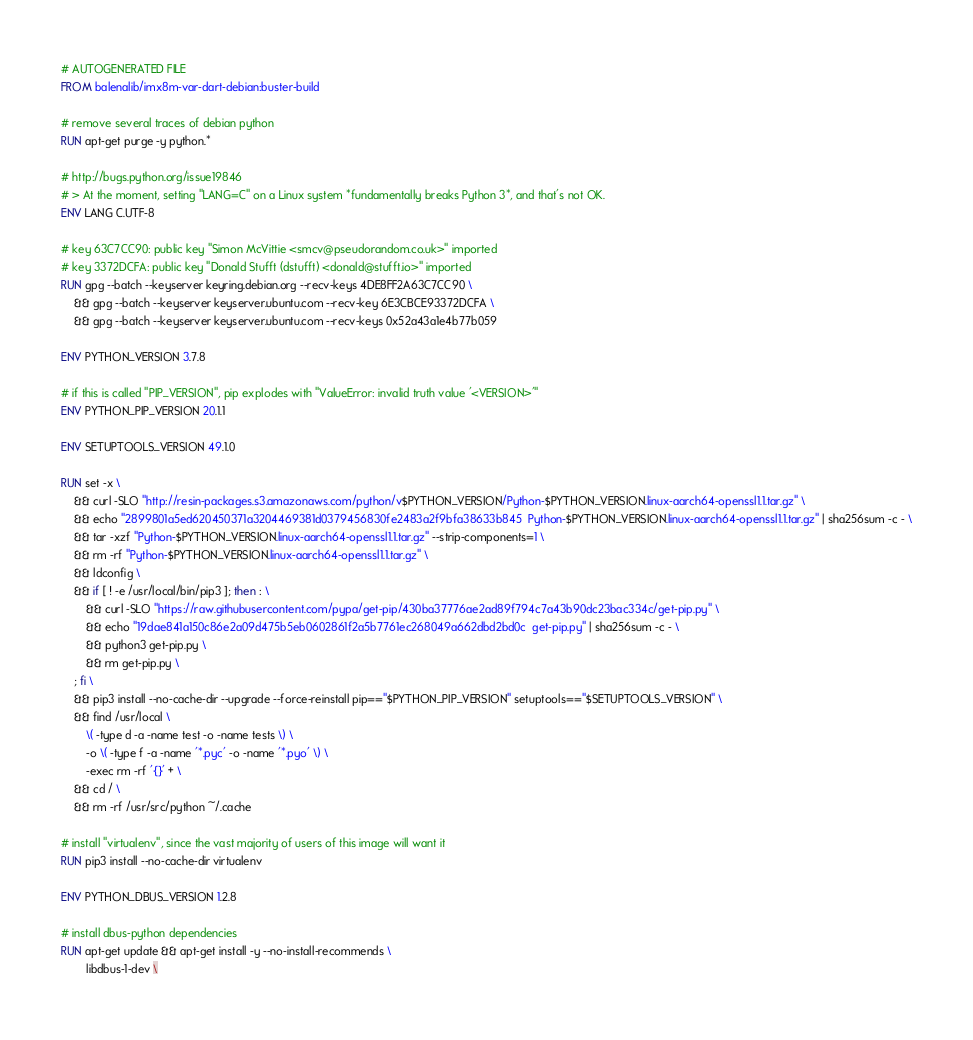<code> <loc_0><loc_0><loc_500><loc_500><_Dockerfile_># AUTOGENERATED FILE
FROM balenalib/imx8m-var-dart-debian:buster-build

# remove several traces of debian python
RUN apt-get purge -y python.*

# http://bugs.python.org/issue19846
# > At the moment, setting "LANG=C" on a Linux system *fundamentally breaks Python 3*, and that's not OK.
ENV LANG C.UTF-8

# key 63C7CC90: public key "Simon McVittie <smcv@pseudorandom.co.uk>" imported
# key 3372DCFA: public key "Donald Stufft (dstufft) <donald@stufft.io>" imported
RUN gpg --batch --keyserver keyring.debian.org --recv-keys 4DE8FF2A63C7CC90 \
	&& gpg --batch --keyserver keyserver.ubuntu.com --recv-key 6E3CBCE93372DCFA \
	&& gpg --batch --keyserver keyserver.ubuntu.com --recv-keys 0x52a43a1e4b77b059

ENV PYTHON_VERSION 3.7.8

# if this is called "PIP_VERSION", pip explodes with "ValueError: invalid truth value '<VERSION>'"
ENV PYTHON_PIP_VERSION 20.1.1

ENV SETUPTOOLS_VERSION 49.1.0

RUN set -x \
	&& curl -SLO "http://resin-packages.s3.amazonaws.com/python/v$PYTHON_VERSION/Python-$PYTHON_VERSION.linux-aarch64-openssl1.1.tar.gz" \
	&& echo "2899801a5ed620450371a3204469381d0379456830fe2483a2f9bfa38633b845  Python-$PYTHON_VERSION.linux-aarch64-openssl1.1.tar.gz" | sha256sum -c - \
	&& tar -xzf "Python-$PYTHON_VERSION.linux-aarch64-openssl1.1.tar.gz" --strip-components=1 \
	&& rm -rf "Python-$PYTHON_VERSION.linux-aarch64-openssl1.1.tar.gz" \
	&& ldconfig \
	&& if [ ! -e /usr/local/bin/pip3 ]; then : \
		&& curl -SLO "https://raw.githubusercontent.com/pypa/get-pip/430ba37776ae2ad89f794c7a43b90dc23bac334c/get-pip.py" \
		&& echo "19dae841a150c86e2a09d475b5eb0602861f2a5b7761ec268049a662dbd2bd0c  get-pip.py" | sha256sum -c - \
		&& python3 get-pip.py \
		&& rm get-pip.py \
	; fi \
	&& pip3 install --no-cache-dir --upgrade --force-reinstall pip=="$PYTHON_PIP_VERSION" setuptools=="$SETUPTOOLS_VERSION" \
	&& find /usr/local \
		\( -type d -a -name test -o -name tests \) \
		-o \( -type f -a -name '*.pyc' -o -name '*.pyo' \) \
		-exec rm -rf '{}' + \
	&& cd / \
	&& rm -rf /usr/src/python ~/.cache

# install "virtualenv", since the vast majority of users of this image will want it
RUN pip3 install --no-cache-dir virtualenv

ENV PYTHON_DBUS_VERSION 1.2.8

# install dbus-python dependencies 
RUN apt-get update && apt-get install -y --no-install-recommends \
		libdbus-1-dev \</code> 